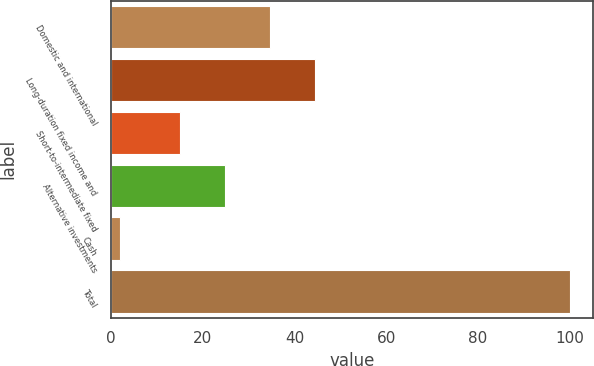Convert chart to OTSL. <chart><loc_0><loc_0><loc_500><loc_500><bar_chart><fcel>Domestic and international<fcel>Long-duration fixed income and<fcel>Short-to-intermediate fixed<fcel>Alternative investments<fcel>Cash<fcel>Total<nl><fcel>34.6<fcel>44.4<fcel>15<fcel>24.8<fcel>2<fcel>100<nl></chart> 